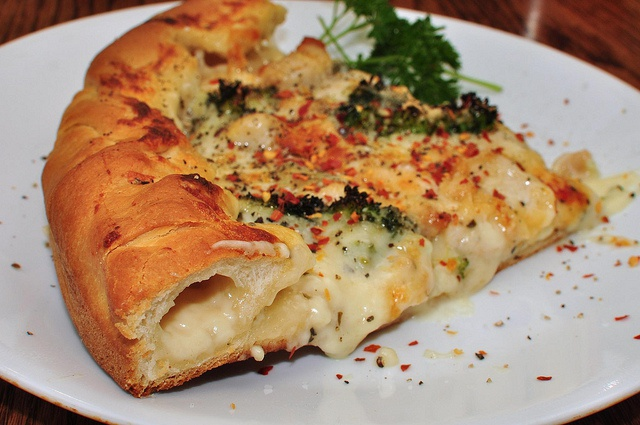Describe the objects in this image and their specific colors. I can see a pizza in maroon, brown, tan, and red tones in this image. 